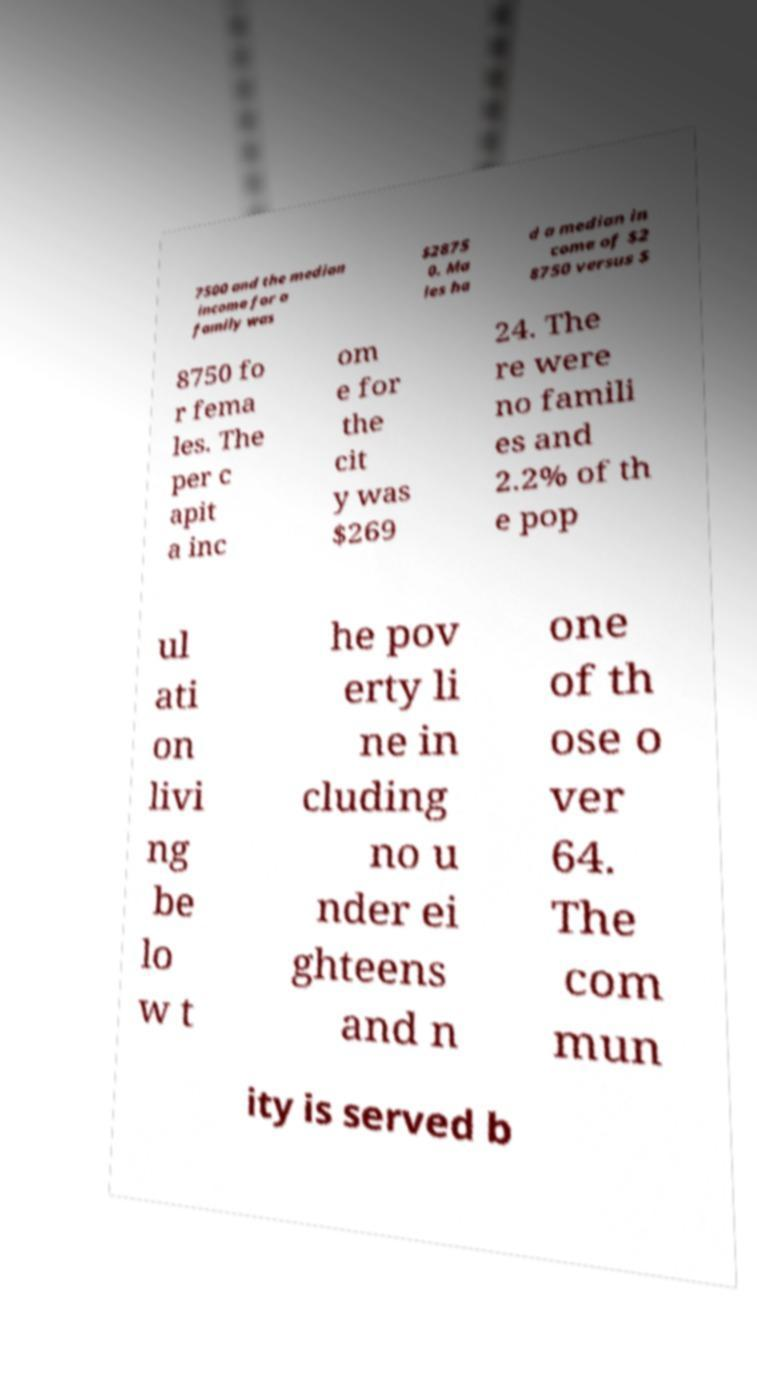Please identify and transcribe the text found in this image. 7500 and the median income for a family was $2875 0. Ma les ha d a median in come of $2 8750 versus $ 8750 fo r fema les. The per c apit a inc om e for the cit y was $269 24. The re were no famili es and 2.2% of th e pop ul ati on livi ng be lo w t he pov erty li ne in cluding no u nder ei ghteens and n one of th ose o ver 64. The com mun ity is served b 